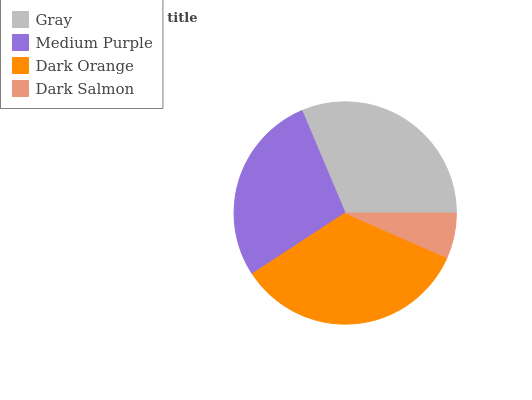Is Dark Salmon the minimum?
Answer yes or no. Yes. Is Dark Orange the maximum?
Answer yes or no. Yes. Is Medium Purple the minimum?
Answer yes or no. No. Is Medium Purple the maximum?
Answer yes or no. No. Is Gray greater than Medium Purple?
Answer yes or no. Yes. Is Medium Purple less than Gray?
Answer yes or no. Yes. Is Medium Purple greater than Gray?
Answer yes or no. No. Is Gray less than Medium Purple?
Answer yes or no. No. Is Gray the high median?
Answer yes or no. Yes. Is Medium Purple the low median?
Answer yes or no. Yes. Is Dark Orange the high median?
Answer yes or no. No. Is Gray the low median?
Answer yes or no. No. 